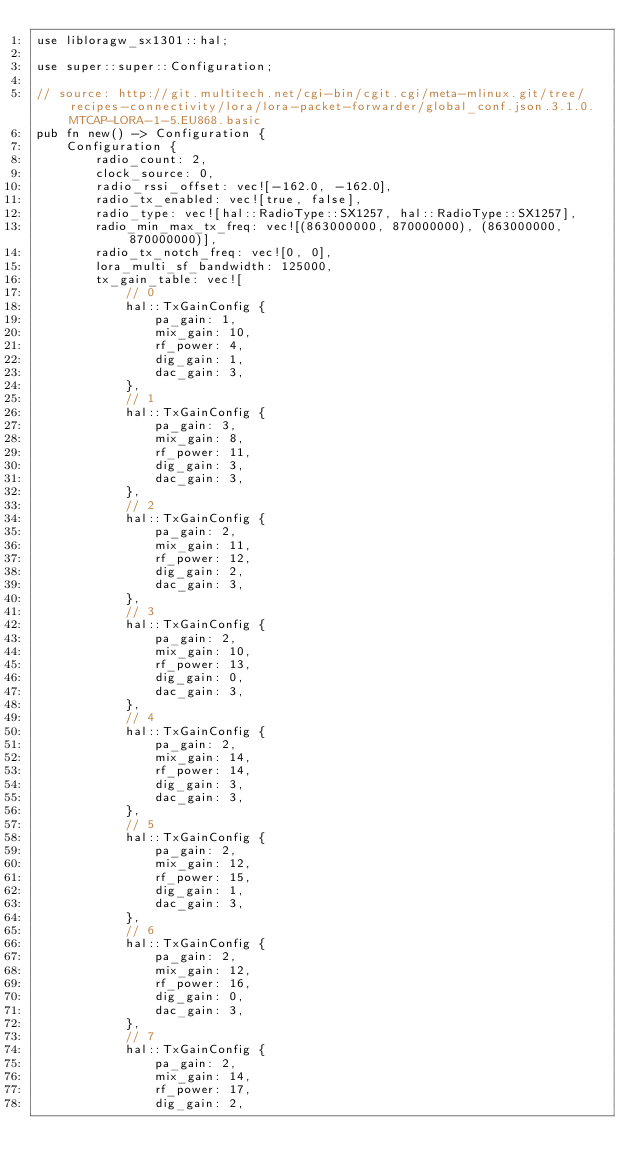<code> <loc_0><loc_0><loc_500><loc_500><_Rust_>use libloragw_sx1301::hal;

use super::super::Configuration;

// source: http://git.multitech.net/cgi-bin/cgit.cgi/meta-mlinux.git/tree/recipes-connectivity/lora/lora-packet-forwarder/global_conf.json.3.1.0.MTCAP-LORA-1-5.EU868.basic
pub fn new() -> Configuration {
    Configuration {
        radio_count: 2,
        clock_source: 0,
        radio_rssi_offset: vec![-162.0, -162.0],
        radio_tx_enabled: vec![true, false],
        radio_type: vec![hal::RadioType::SX1257, hal::RadioType::SX1257],
        radio_min_max_tx_freq: vec![(863000000, 870000000), (863000000, 870000000)],
        radio_tx_notch_freq: vec![0, 0],
        lora_multi_sf_bandwidth: 125000,
        tx_gain_table: vec![
            // 0
            hal::TxGainConfig {
                pa_gain: 1,
                mix_gain: 10,
                rf_power: 4,
                dig_gain: 1,
                dac_gain: 3,
            },
            // 1
            hal::TxGainConfig {
                pa_gain: 3,
                mix_gain: 8,
                rf_power: 11,
                dig_gain: 3,
                dac_gain: 3,
            },
            // 2
            hal::TxGainConfig {
                pa_gain: 2,
                mix_gain: 11,
                rf_power: 12,
                dig_gain: 2,
                dac_gain: 3,
            },
            // 3
            hal::TxGainConfig {
                pa_gain: 2,
                mix_gain: 10,
                rf_power: 13,
                dig_gain: 0,
                dac_gain: 3,
            },
            // 4
            hal::TxGainConfig {
                pa_gain: 2,
                mix_gain: 14,
                rf_power: 14,
                dig_gain: 3,
                dac_gain: 3,
            },
            // 5
            hal::TxGainConfig {
                pa_gain: 2,
                mix_gain: 12,
                rf_power: 15,
                dig_gain: 1,
                dac_gain: 3,
            },
            // 6
            hal::TxGainConfig {
                pa_gain: 2,
                mix_gain: 12,
                rf_power: 16,
                dig_gain: 0,
                dac_gain: 3,
            },
            // 7
            hal::TxGainConfig {
                pa_gain: 2,
                mix_gain: 14,
                rf_power: 17,
                dig_gain: 2,</code> 